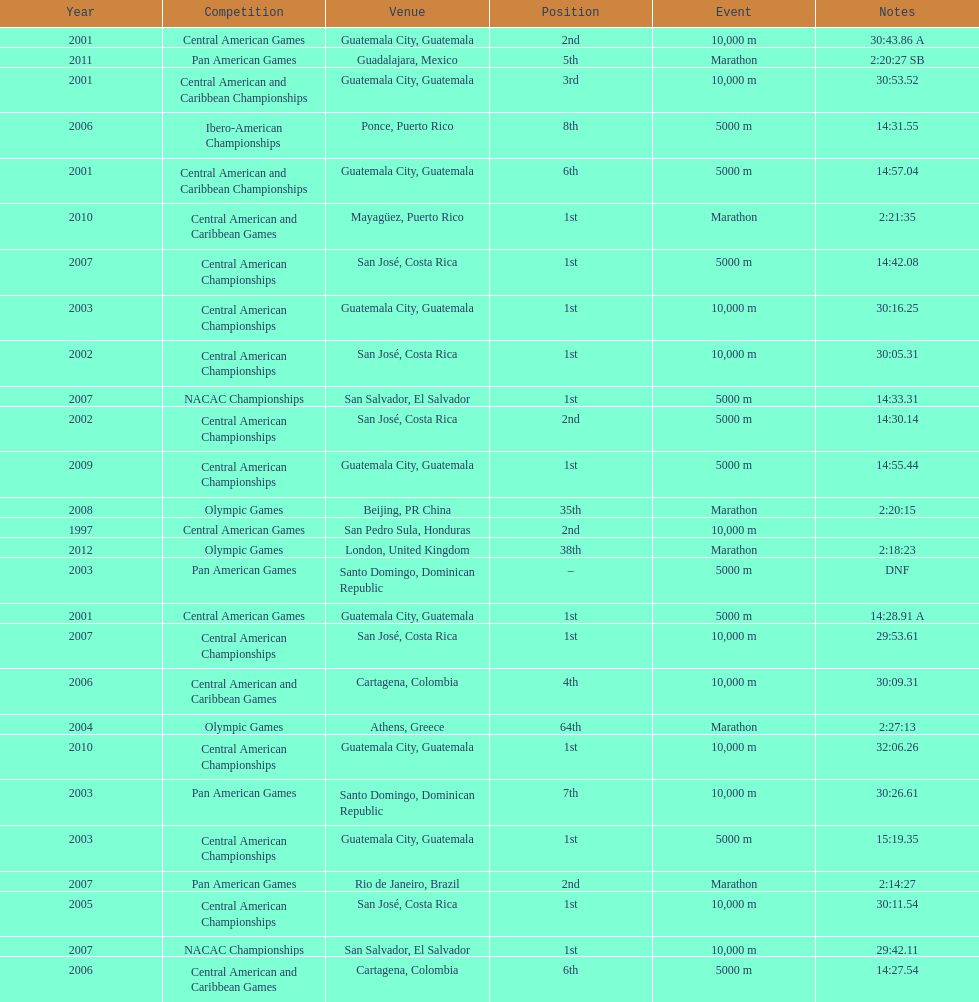How many times has the position of 1st been achieved? 12. 